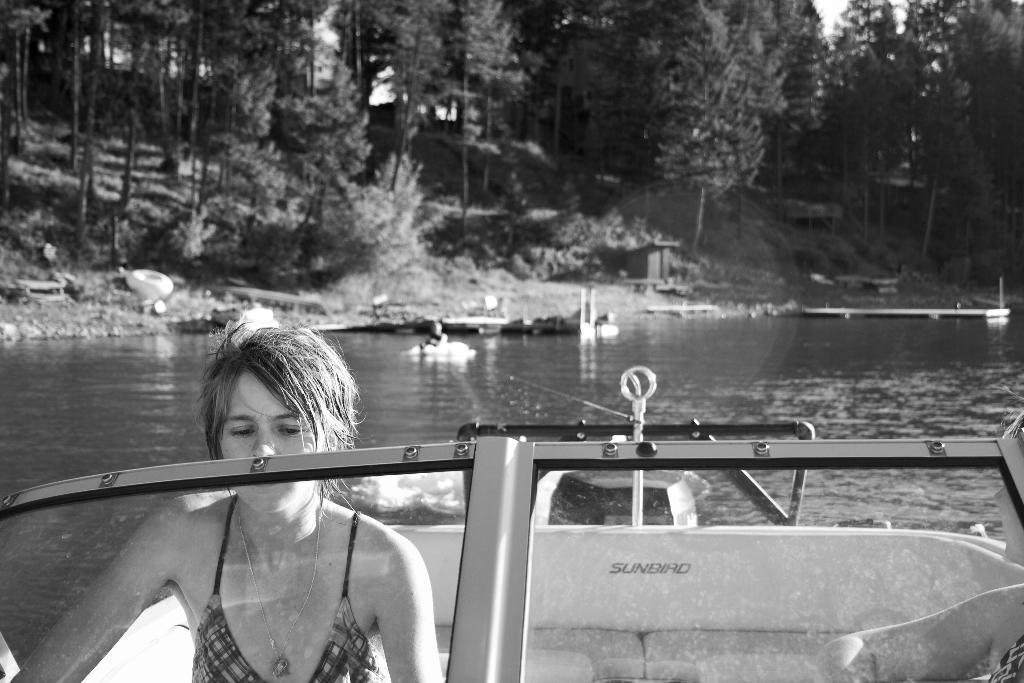Who is present in the image? There is a woman in the image. What is the woman doing in the image? The woman is on a boat. Can you describe the person behind the woman? There is a person at the back of the woman. What can be seen in the image besides the people? There is water visible in the image, and there are objects present as well. What is visible in the background of the image? There are trees in the background of the image. What type of soup is being served in the image? There is no soup present in the image; it features a woman on a boat with a person behind her, water, objects, and trees in the background. 